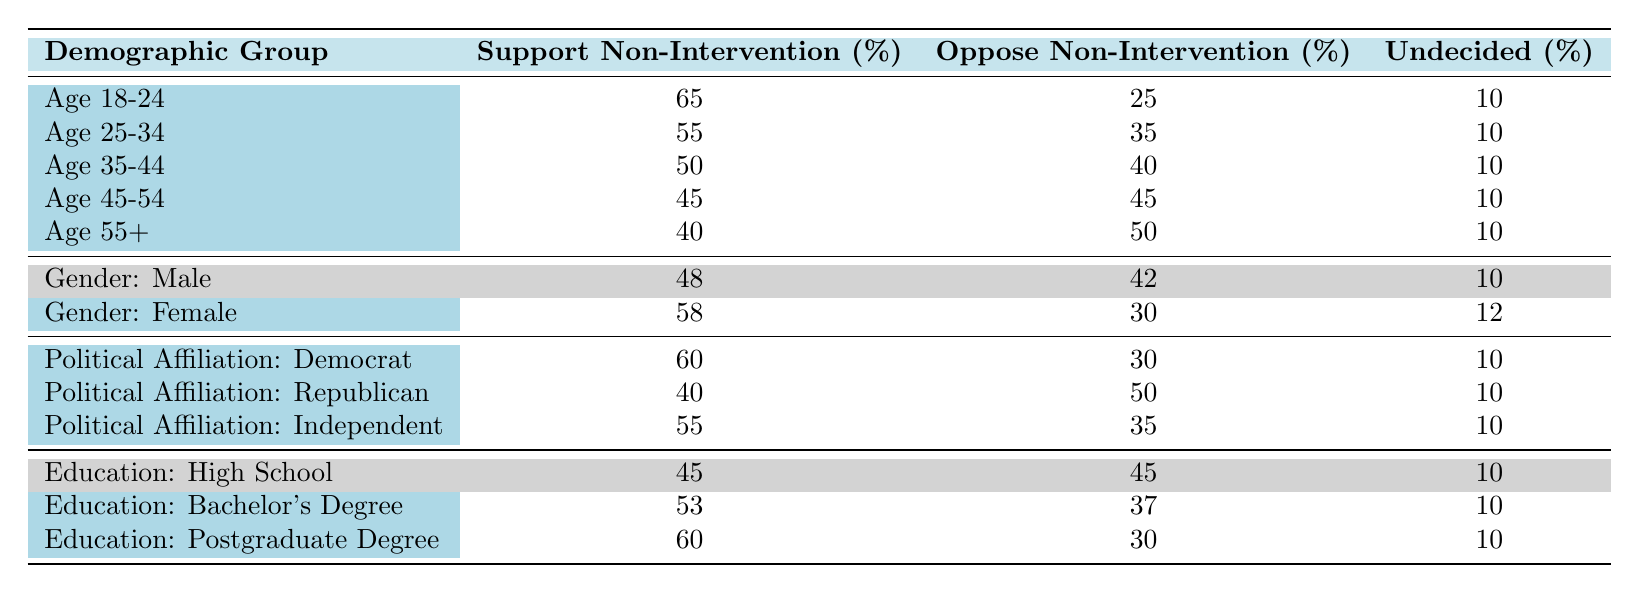What percentage of the demographic group "Age 18-24" supports non-intervention? The table shows that in the "Age 18-24" group, the percentage supporting non-intervention is 65.
Answer: 65 What is the overall percentage of those who oppose non-intervention in the age group "55+"? The table indicates that in the "Age 55+" demographic, 50% oppose non-intervention.
Answer: 50 How does the support for non-intervention among "Political Affiliation: Democrat" compare to "Political Affiliation: Republican"? The support for non-intervention is 60% for Democrats and 40% for Republicans. The difference is 60 - 40 = 20, meaning Democrats support non-intervention 20% more than Republicans.
Answer: 20% Is it true that the majority of the "Gender: Female" demographic supports non-intervention? The table states that 58% of women support non-intervention, which is indeed more than 50%. Thus, it is true that a majority supports it.
Answer: Yes What is the average percentage of support for non-intervention across all age groups? To find the average, sum the support percentages (65 + 55 + 50 + 45 + 40) = 255, then divide by the number of groups (5), resulting in 255 / 5 = 51.
Answer: 51 What percentage of "Gender: Male" opposes non-intervention? In the "Gender: Male" row, the table states that 42% oppose non-intervention.
Answer: 42 Which demographic group shows the highest level of support for non-intervention? The "Age 18-24" group has the highest support at 65%. This is confirmed by comparing all support percentages of other groups.
Answer: Age 18-24 If the "Political Affiliation: Independent" group supports non-intervention at 55%, does this group have a higher or lower percentage of support compared to the "Age 45-54" group? The "Age 45-54" group has a support percentage of 45%. Since 55% is greater than 45%, the Independent group has higher support.
Answer: Higher What is the difference in percentage of support for non-intervention between the "Education: Postgraduate Degree" and "Education: Bachelor's Degree"? The support for postgraduate degrees is 60% and for bachelor's degrees is 53%. The difference is 60 - 53 = 7.
Answer: 7 